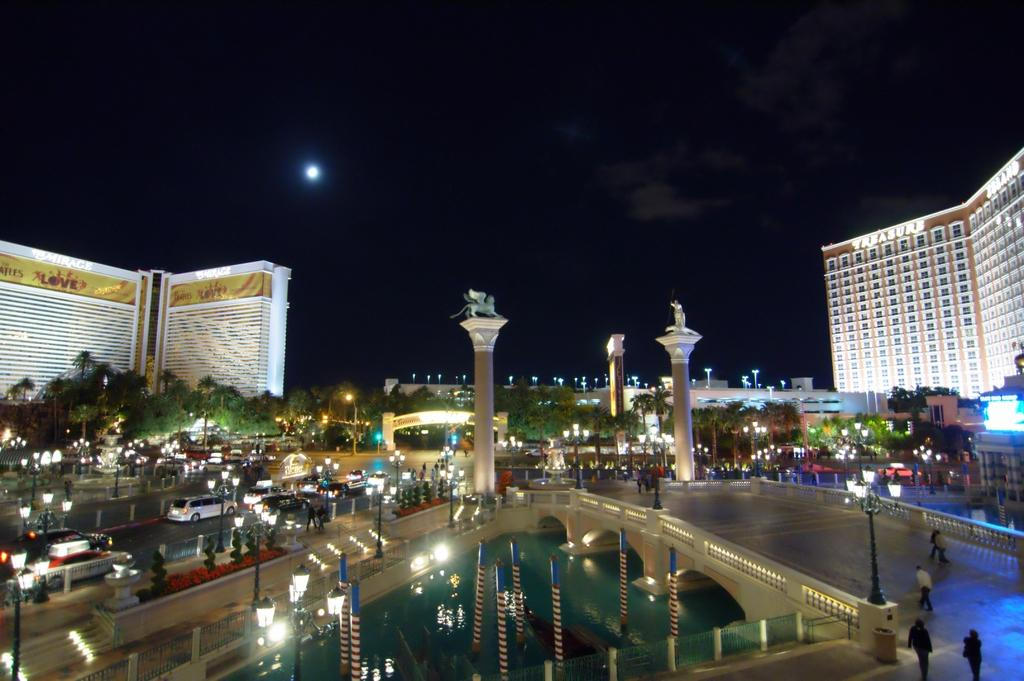What type of vehicles can be seen on the road in the image? There are cars on the road in the image. What natural elements are present in the image? There are trees in the image. What artificial elements are present in the image? There are lights, buildings, and a bridge in the image. What is visible in the background of the image? The sky is visible in the background of the image. Where are the people located in the image? The people are on a bridge in the image. What color is the blood on the sock in the image? There is no blood or sock present in the image. What type of tank is visible in the image? There is no tank present in the image. 